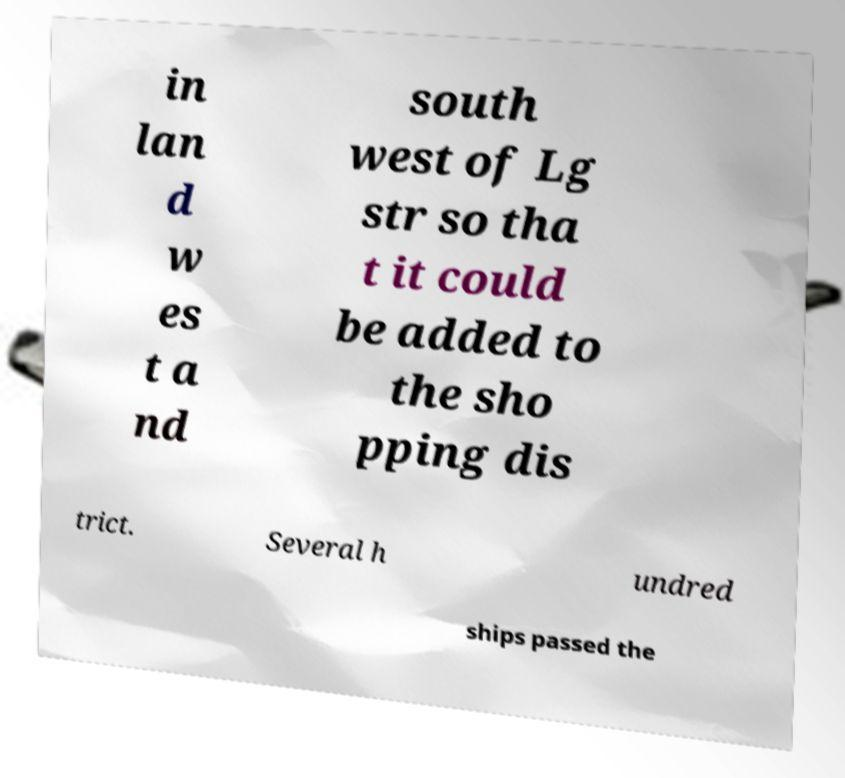Could you extract and type out the text from this image? in lan d w es t a nd south west of Lg str so tha t it could be added to the sho pping dis trict. Several h undred ships passed the 